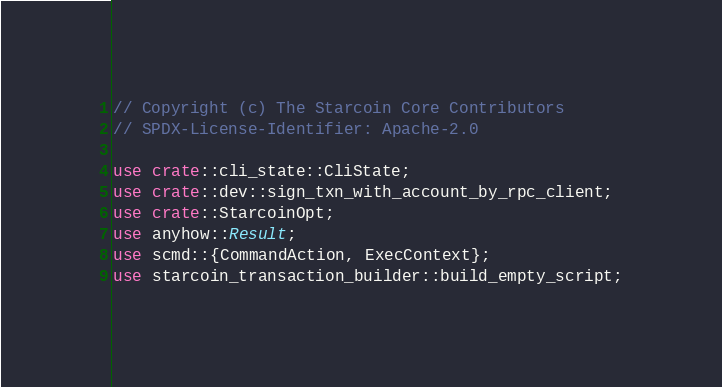<code> <loc_0><loc_0><loc_500><loc_500><_Rust_>// Copyright (c) The Starcoin Core Contributors
// SPDX-License-Identifier: Apache-2.0

use crate::cli_state::CliState;
use crate::dev::sign_txn_with_account_by_rpc_client;
use crate::StarcoinOpt;
use anyhow::Result;
use scmd::{CommandAction, ExecContext};
use starcoin_transaction_builder::build_empty_script;</code> 